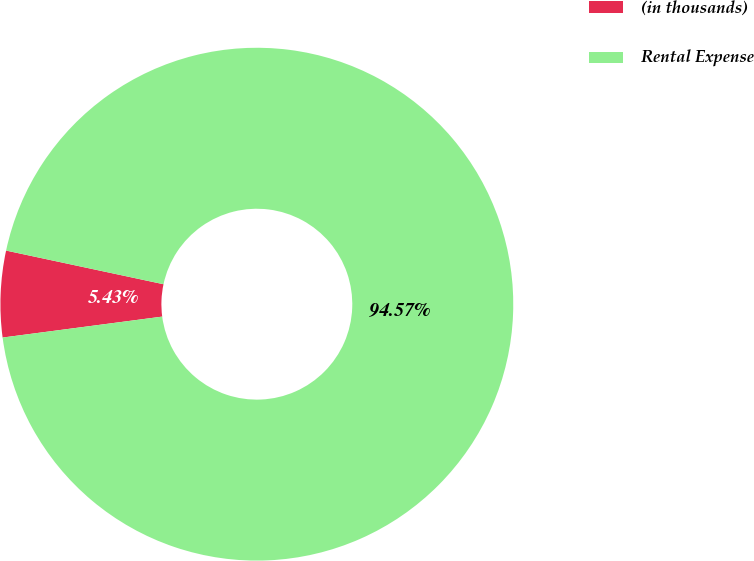Convert chart. <chart><loc_0><loc_0><loc_500><loc_500><pie_chart><fcel>(in thousands)<fcel>Rental Expense<nl><fcel>5.43%<fcel>94.57%<nl></chart> 